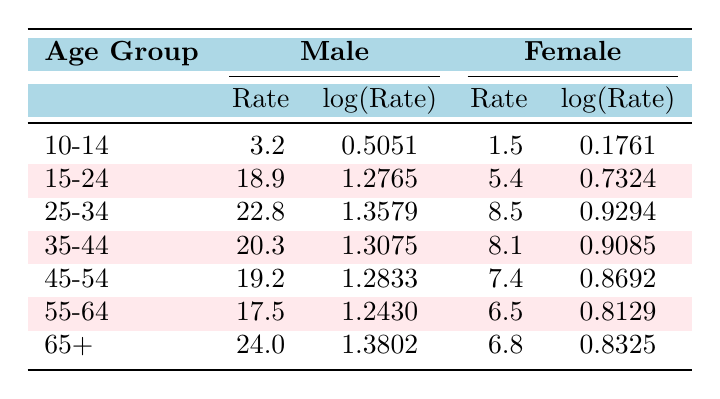What is the suicide rate for males aged 10-14? From the table, in the row corresponding to the 10-14 age group under the Male column, the rate is listed as 3.2.
Answer: 3.2 What is the suicide rate for females aged 15-24? The table shows that in the row for the 15-24 age group under the Female column, the rate is 5.4.
Answer: 5.4 Which age group has the highest suicide rate for males? Upon examining the Male rates, the highest value is found in the 65+ age group, where the rate is 24.0.
Answer: 65+ Is the suicide rate for females higher in the 25-34 age group or the 15-24 age group? Comparing the two rates, the 25-34 age group's female rate is 8.5, while the 15-24 age group's female rate is 5.4. Since 8.5 is greater than 5.4, the 25-34 age group has a higher rate.
Answer: 25-34 What is the total suicide rate for males in the age groups of 15-24 and 25-34 combined? We need to sum the male rates from both age groups: 18.9 (15-24) + 22.8 (25-34) = 41.7.
Answer: 41.7 Is there a lower male suicide rate in the 55-64 age group compared to the 10-14 age group? The male rate for 55-64 is 17.5, and for 10-14 it is 3.2. Since 17.5 is greater than 3.2, the statement is false.
Answer: No What is the average suicide rate for females across all age groups? To find the average, sum the female rates: 1.5 + 5.4 + 8.5 + 8.1 + 7.4 + 6.5 + 6.8 = 44.4. There are 7 age groups, so we divide: 44.4 / 7 = 6.34.
Answer: 6.34 Which gender has a higher suicide rate in the 35-44 age group? For the 35-44 age group, the male rate is 20.3 and the female rate is 8.1. Since 20.3 is greater than 8.1, males have a higher rate.
Answer: Male If you combine the rates of all male age groups in total, what is the sum? The total sum for males is calculated by adding: 3.2 + 18.9 + 22.8 + 20.3 + 19.2 + 17.5 + 24.0 = 125.9.
Answer: 125.9 